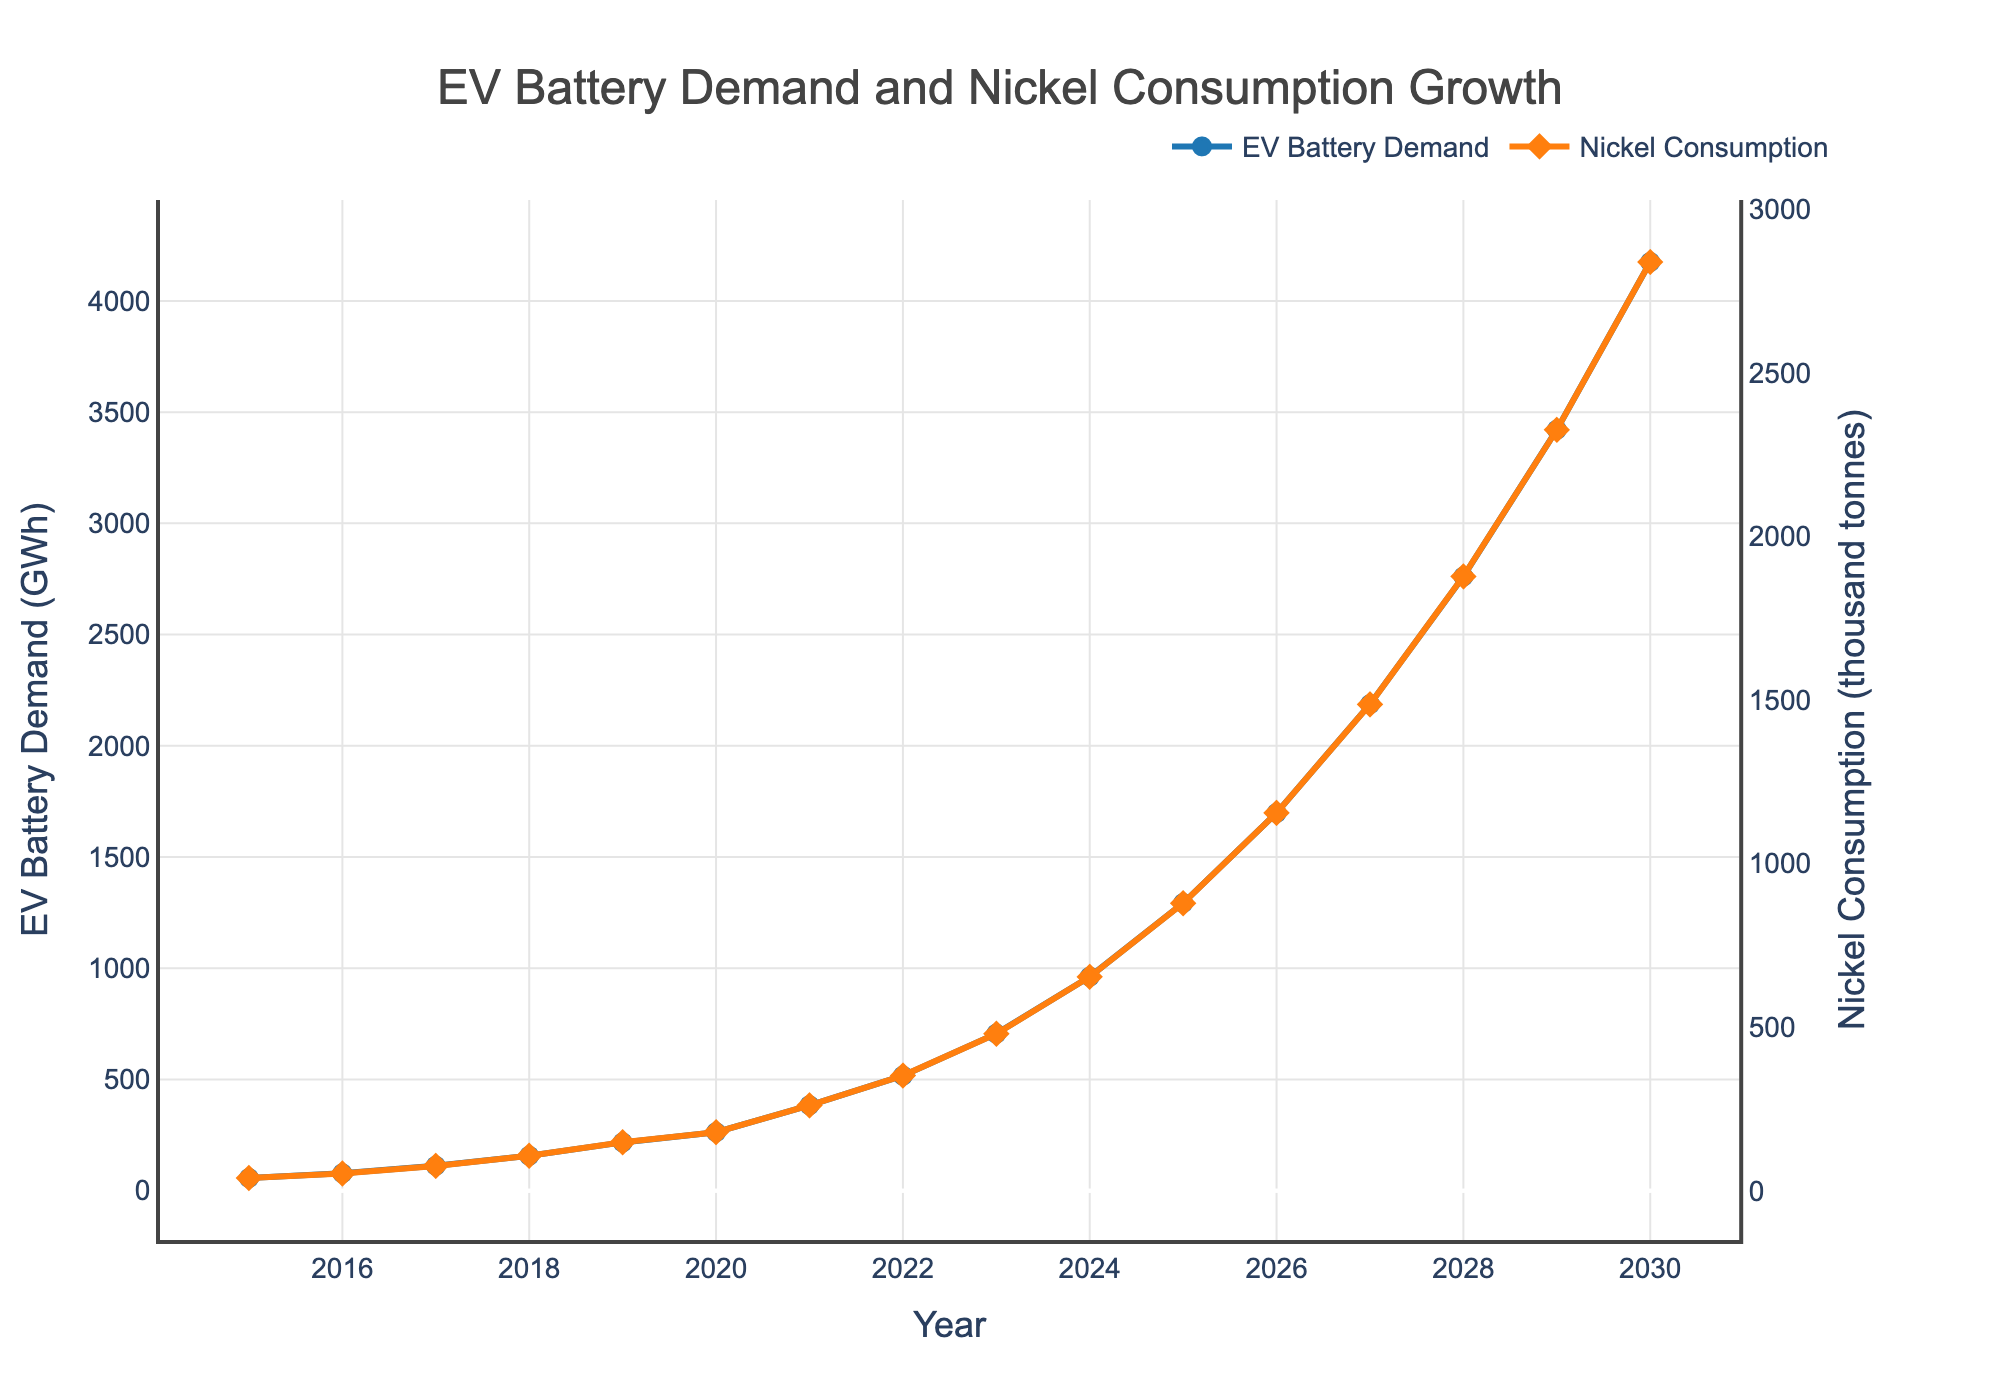What is the EV battery demand in 2020? Look at the data point on the blue line labeled "EV Battery Demand" for the year 2020. The corresponding value will be the EV battery demand.
Answer: 263 GWh What is the difference in nickel consumption for EV batteries between 2017 and 2020? Subtract the value of nickel consumption in 2017 from the value in 2020. From the orange line labeled "Nickel Consumption for EV Batteries," you can see 76 thousand tonnes for 2017 and 179 thousand tonnes for 2020. So, the difference is 179 - 76.
Answer: 103 thousand tonnes Between which years is the sharpest increase in EV battery demand observed? Identify the largest vertical distance between consecutive blue data points ("EV Battery Demand") on the chart. Observe the difference from year to year. The sharpest increase is between 2022 and 2023.
Answer: 2022 and 2023 Is the trend of nickel consumption for EV batteries linear or non-linear? Observe the shape of the line representing nickel consumption (orange line). If it resembles a straight line, it's linear; if it curves or varies in slope, it's non-linear. The trend shows an upward curve, indicating a non-linear trend.
Answer: Non-linear What is the average annual increase in EV battery demand from 2015 to 2020? Calculate the average increase in EV battery demand from 2015 to 2020. The difference between the values for 2020 and 2015 is 263 - 57 = 206 GWh. Divide this by the number of years (2020 - 2015 = 5 years).
Answer: 41.2 GWh/year When does nickel consumption for EV batteries first exceed 1000 thousand tonnes? Look for the first data point on the orange line where the value is greater than 1000 thousand tonnes. This occurs in 2026.
Answer: 2026 By how much does nickel consumption for EV batteries exceed EV battery demand in 2030? In 2030, the EV battery demand is 4175 GWh and nickel consumption is 2839 thousand tonnes. Subtract the EV battery demand from the nickel consumption: 2839 - 4175. However, since the units are different (GWh vs. thousand tonnes), interpret this as "comparing," not subtracting.
Answer: Cannot be directly subtracted Which year sees a higher percentage increase in nickel consumption compared to the previous year, 2024 or 2025? Calculate the percentage increase for both years. For 2024: ((879 - 654) / 654) * 100 = 34.4%. For 2025: ((1155 - 879) / 879) * 100 = 31.4%. So, 2024 has a higher percentage increase.
Answer: 2024 